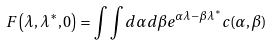Convert formula to latex. <formula><loc_0><loc_0><loc_500><loc_500>F \left ( \lambda , \lambda ^ { * } , 0 \right ) = \int \int d \alpha d \beta e ^ { \alpha \lambda - \beta \lambda ^ { * } } c ( \alpha , \beta )</formula> 